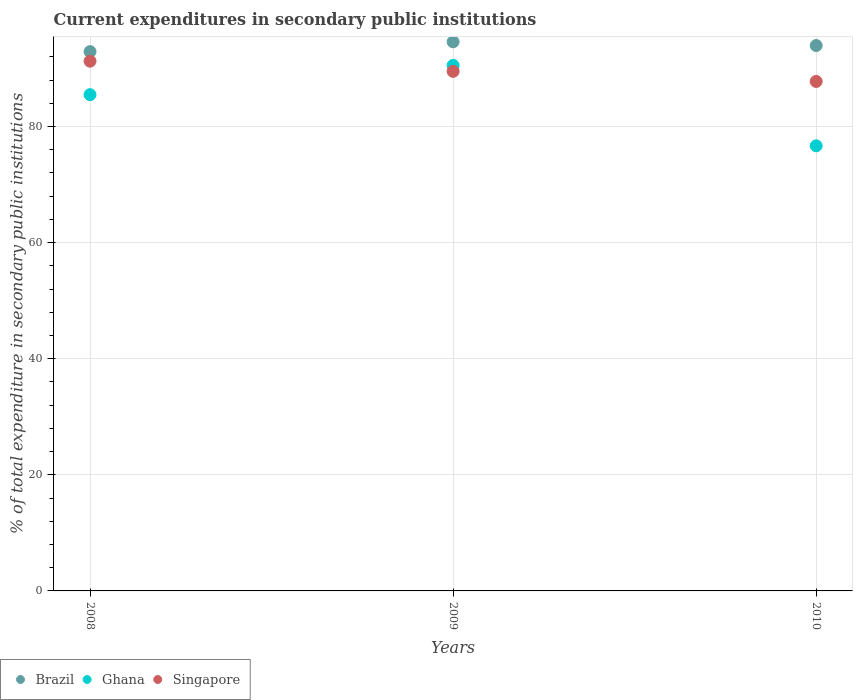What is the current expenditures in secondary public institutions in Singapore in 2010?
Your response must be concise. 87.75. Across all years, what is the maximum current expenditures in secondary public institutions in Brazil?
Ensure brevity in your answer.  94.59. Across all years, what is the minimum current expenditures in secondary public institutions in Singapore?
Offer a very short reply. 87.75. What is the total current expenditures in secondary public institutions in Singapore in the graph?
Provide a short and direct response. 268.49. What is the difference between the current expenditures in secondary public institutions in Singapore in 2008 and that in 2010?
Your answer should be very brief. 3.49. What is the difference between the current expenditures in secondary public institutions in Brazil in 2009 and the current expenditures in secondary public institutions in Singapore in 2010?
Offer a terse response. 6.83. What is the average current expenditures in secondary public institutions in Ghana per year?
Provide a short and direct response. 84.22. In the year 2009, what is the difference between the current expenditures in secondary public institutions in Singapore and current expenditures in secondary public institutions in Ghana?
Provide a short and direct response. -1.03. In how many years, is the current expenditures in secondary public institutions in Singapore greater than 28 %?
Ensure brevity in your answer.  3. What is the ratio of the current expenditures in secondary public institutions in Singapore in 2008 to that in 2010?
Your response must be concise. 1.04. Is the current expenditures in secondary public institutions in Singapore in 2009 less than that in 2010?
Provide a succinct answer. No. What is the difference between the highest and the second highest current expenditures in secondary public institutions in Ghana?
Provide a short and direct response. 5.04. What is the difference between the highest and the lowest current expenditures in secondary public institutions in Singapore?
Offer a terse response. 3.49. Does the current expenditures in secondary public institutions in Ghana monotonically increase over the years?
Provide a short and direct response. No. Is the current expenditures in secondary public institutions in Singapore strictly less than the current expenditures in secondary public institutions in Brazil over the years?
Your answer should be very brief. Yes. Are the values on the major ticks of Y-axis written in scientific E-notation?
Your response must be concise. No. Does the graph contain any zero values?
Your answer should be compact. No. Does the graph contain grids?
Make the answer very short. Yes. How are the legend labels stacked?
Give a very brief answer. Horizontal. What is the title of the graph?
Keep it short and to the point. Current expenditures in secondary public institutions. Does "Middle East & North Africa (all income levels)" appear as one of the legend labels in the graph?
Give a very brief answer. No. What is the label or title of the Y-axis?
Offer a very short reply. % of total expenditure in secondary public institutions. What is the % of total expenditure in secondary public institutions of Brazil in 2008?
Offer a terse response. 92.89. What is the % of total expenditure in secondary public institutions in Ghana in 2008?
Give a very brief answer. 85.48. What is the % of total expenditure in secondary public institutions in Singapore in 2008?
Make the answer very short. 91.24. What is the % of total expenditure in secondary public institutions in Brazil in 2009?
Provide a succinct answer. 94.59. What is the % of total expenditure in secondary public institutions in Ghana in 2009?
Ensure brevity in your answer.  90.52. What is the % of total expenditure in secondary public institutions in Singapore in 2009?
Provide a succinct answer. 89.49. What is the % of total expenditure in secondary public institutions of Brazil in 2010?
Your answer should be very brief. 93.94. What is the % of total expenditure in secondary public institutions in Ghana in 2010?
Offer a terse response. 76.67. What is the % of total expenditure in secondary public institutions in Singapore in 2010?
Provide a succinct answer. 87.75. Across all years, what is the maximum % of total expenditure in secondary public institutions in Brazil?
Offer a very short reply. 94.59. Across all years, what is the maximum % of total expenditure in secondary public institutions in Ghana?
Your answer should be very brief. 90.52. Across all years, what is the maximum % of total expenditure in secondary public institutions of Singapore?
Your response must be concise. 91.24. Across all years, what is the minimum % of total expenditure in secondary public institutions of Brazil?
Your answer should be very brief. 92.89. Across all years, what is the minimum % of total expenditure in secondary public institutions of Ghana?
Your response must be concise. 76.67. Across all years, what is the minimum % of total expenditure in secondary public institutions of Singapore?
Ensure brevity in your answer.  87.75. What is the total % of total expenditure in secondary public institutions in Brazil in the graph?
Your answer should be compact. 281.41. What is the total % of total expenditure in secondary public institutions in Ghana in the graph?
Ensure brevity in your answer.  252.66. What is the total % of total expenditure in secondary public institutions in Singapore in the graph?
Your answer should be very brief. 268.49. What is the difference between the % of total expenditure in secondary public institutions of Brazil in 2008 and that in 2009?
Provide a succinct answer. -1.7. What is the difference between the % of total expenditure in secondary public institutions in Ghana in 2008 and that in 2009?
Make the answer very short. -5.04. What is the difference between the % of total expenditure in secondary public institutions in Singapore in 2008 and that in 2009?
Offer a terse response. 1.75. What is the difference between the % of total expenditure in secondary public institutions of Brazil in 2008 and that in 2010?
Make the answer very short. -1.05. What is the difference between the % of total expenditure in secondary public institutions in Ghana in 2008 and that in 2010?
Provide a succinct answer. 8.81. What is the difference between the % of total expenditure in secondary public institutions in Singapore in 2008 and that in 2010?
Provide a succinct answer. 3.49. What is the difference between the % of total expenditure in secondary public institutions of Brazil in 2009 and that in 2010?
Your answer should be compact. 0.65. What is the difference between the % of total expenditure in secondary public institutions of Ghana in 2009 and that in 2010?
Make the answer very short. 13.85. What is the difference between the % of total expenditure in secondary public institutions of Singapore in 2009 and that in 2010?
Offer a very short reply. 1.74. What is the difference between the % of total expenditure in secondary public institutions in Brazil in 2008 and the % of total expenditure in secondary public institutions in Ghana in 2009?
Provide a succinct answer. 2.37. What is the difference between the % of total expenditure in secondary public institutions in Brazil in 2008 and the % of total expenditure in secondary public institutions in Singapore in 2009?
Your answer should be very brief. 3.4. What is the difference between the % of total expenditure in secondary public institutions in Ghana in 2008 and the % of total expenditure in secondary public institutions in Singapore in 2009?
Provide a succinct answer. -4.02. What is the difference between the % of total expenditure in secondary public institutions in Brazil in 2008 and the % of total expenditure in secondary public institutions in Ghana in 2010?
Offer a very short reply. 16.22. What is the difference between the % of total expenditure in secondary public institutions of Brazil in 2008 and the % of total expenditure in secondary public institutions of Singapore in 2010?
Keep it short and to the point. 5.14. What is the difference between the % of total expenditure in secondary public institutions of Ghana in 2008 and the % of total expenditure in secondary public institutions of Singapore in 2010?
Offer a terse response. -2.28. What is the difference between the % of total expenditure in secondary public institutions in Brazil in 2009 and the % of total expenditure in secondary public institutions in Ghana in 2010?
Ensure brevity in your answer.  17.92. What is the difference between the % of total expenditure in secondary public institutions in Brazil in 2009 and the % of total expenditure in secondary public institutions in Singapore in 2010?
Offer a terse response. 6.83. What is the difference between the % of total expenditure in secondary public institutions of Ghana in 2009 and the % of total expenditure in secondary public institutions of Singapore in 2010?
Your answer should be compact. 2.77. What is the average % of total expenditure in secondary public institutions in Brazil per year?
Your answer should be very brief. 93.8. What is the average % of total expenditure in secondary public institutions of Ghana per year?
Your answer should be compact. 84.22. What is the average % of total expenditure in secondary public institutions in Singapore per year?
Keep it short and to the point. 89.5. In the year 2008, what is the difference between the % of total expenditure in secondary public institutions in Brazil and % of total expenditure in secondary public institutions in Ghana?
Provide a short and direct response. 7.41. In the year 2008, what is the difference between the % of total expenditure in secondary public institutions in Brazil and % of total expenditure in secondary public institutions in Singapore?
Provide a succinct answer. 1.65. In the year 2008, what is the difference between the % of total expenditure in secondary public institutions of Ghana and % of total expenditure in secondary public institutions of Singapore?
Your answer should be very brief. -5.77. In the year 2009, what is the difference between the % of total expenditure in secondary public institutions of Brazil and % of total expenditure in secondary public institutions of Ghana?
Keep it short and to the point. 4.07. In the year 2009, what is the difference between the % of total expenditure in secondary public institutions of Brazil and % of total expenditure in secondary public institutions of Singapore?
Your response must be concise. 5.09. In the year 2009, what is the difference between the % of total expenditure in secondary public institutions of Ghana and % of total expenditure in secondary public institutions of Singapore?
Keep it short and to the point. 1.03. In the year 2010, what is the difference between the % of total expenditure in secondary public institutions in Brazil and % of total expenditure in secondary public institutions in Ghana?
Provide a succinct answer. 17.27. In the year 2010, what is the difference between the % of total expenditure in secondary public institutions of Brazil and % of total expenditure in secondary public institutions of Singapore?
Give a very brief answer. 6.18. In the year 2010, what is the difference between the % of total expenditure in secondary public institutions in Ghana and % of total expenditure in secondary public institutions in Singapore?
Give a very brief answer. -11.09. What is the ratio of the % of total expenditure in secondary public institutions in Brazil in 2008 to that in 2009?
Your response must be concise. 0.98. What is the ratio of the % of total expenditure in secondary public institutions in Ghana in 2008 to that in 2009?
Keep it short and to the point. 0.94. What is the ratio of the % of total expenditure in secondary public institutions in Singapore in 2008 to that in 2009?
Provide a succinct answer. 1.02. What is the ratio of the % of total expenditure in secondary public institutions in Brazil in 2008 to that in 2010?
Give a very brief answer. 0.99. What is the ratio of the % of total expenditure in secondary public institutions in Ghana in 2008 to that in 2010?
Offer a very short reply. 1.11. What is the ratio of the % of total expenditure in secondary public institutions in Singapore in 2008 to that in 2010?
Provide a short and direct response. 1.04. What is the ratio of the % of total expenditure in secondary public institutions of Brazil in 2009 to that in 2010?
Your answer should be very brief. 1.01. What is the ratio of the % of total expenditure in secondary public institutions of Ghana in 2009 to that in 2010?
Give a very brief answer. 1.18. What is the ratio of the % of total expenditure in secondary public institutions in Singapore in 2009 to that in 2010?
Provide a short and direct response. 1.02. What is the difference between the highest and the second highest % of total expenditure in secondary public institutions in Brazil?
Your answer should be very brief. 0.65. What is the difference between the highest and the second highest % of total expenditure in secondary public institutions in Ghana?
Make the answer very short. 5.04. What is the difference between the highest and the second highest % of total expenditure in secondary public institutions in Singapore?
Provide a short and direct response. 1.75. What is the difference between the highest and the lowest % of total expenditure in secondary public institutions of Brazil?
Offer a terse response. 1.7. What is the difference between the highest and the lowest % of total expenditure in secondary public institutions of Ghana?
Keep it short and to the point. 13.85. What is the difference between the highest and the lowest % of total expenditure in secondary public institutions in Singapore?
Offer a very short reply. 3.49. 